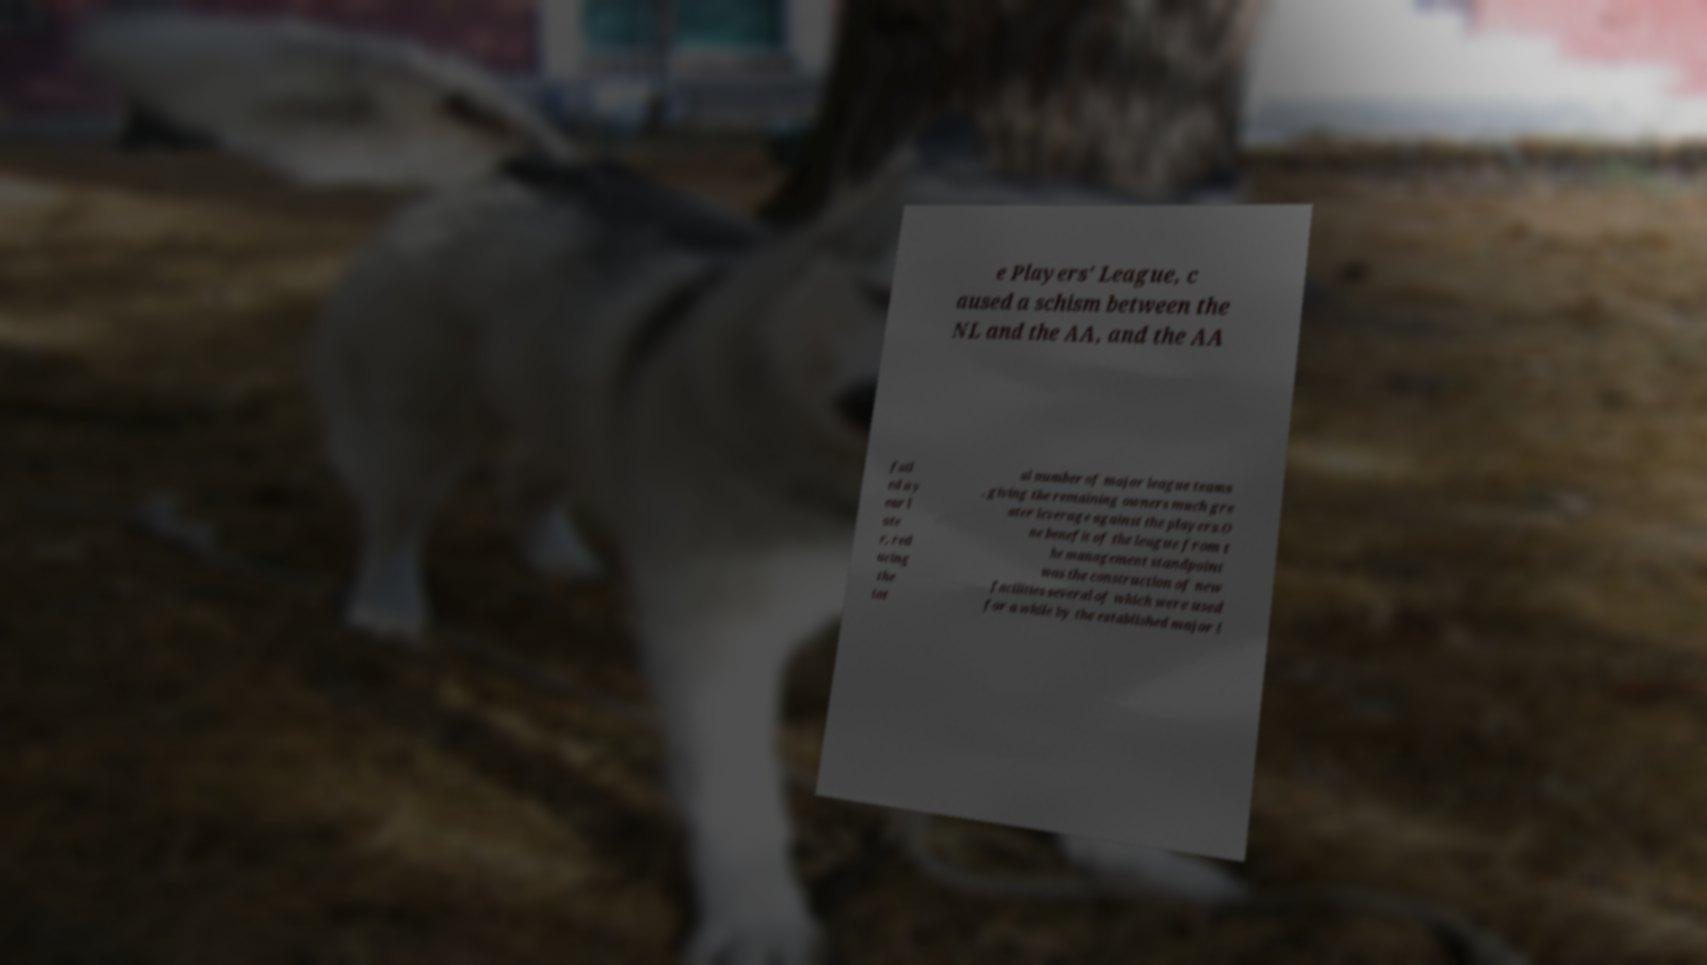Please identify and transcribe the text found in this image. e Players' League, c aused a schism between the NL and the AA, and the AA fail ed a y ear l ate r, red ucing the tot al number of major league teams , giving the remaining owners much gre ater leverage against the players.O ne benefit of the league from t he management standpoint was the construction of new facilities several of which were used for a while by the established major l 